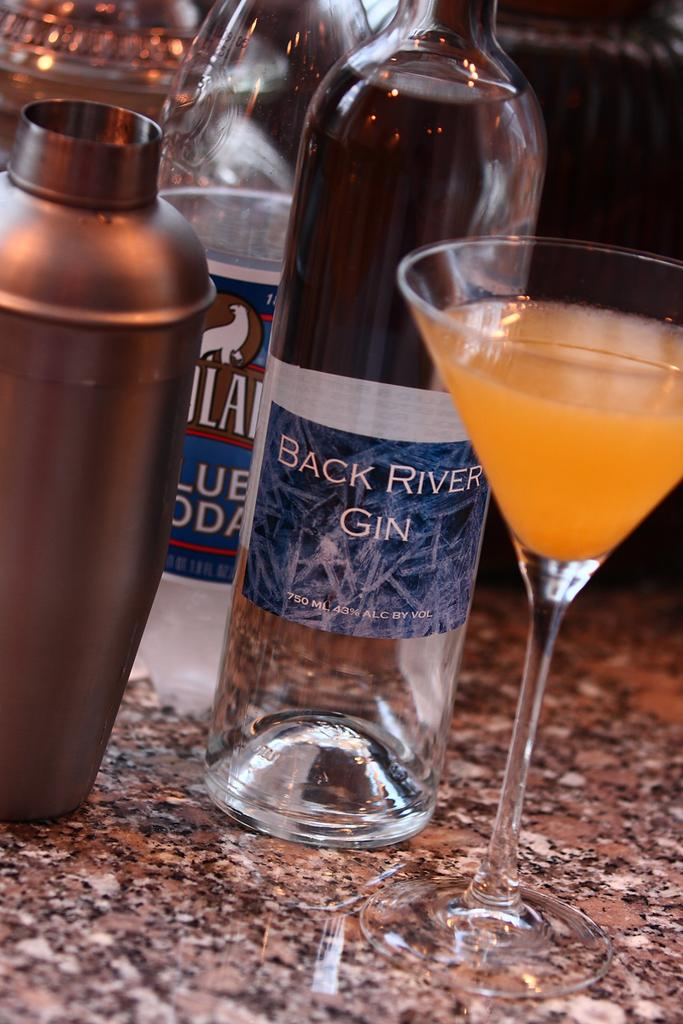<image>
Give a short and clear explanation of the subsequent image. A glass bottle of Back River Gin sets next to a martini glass. 